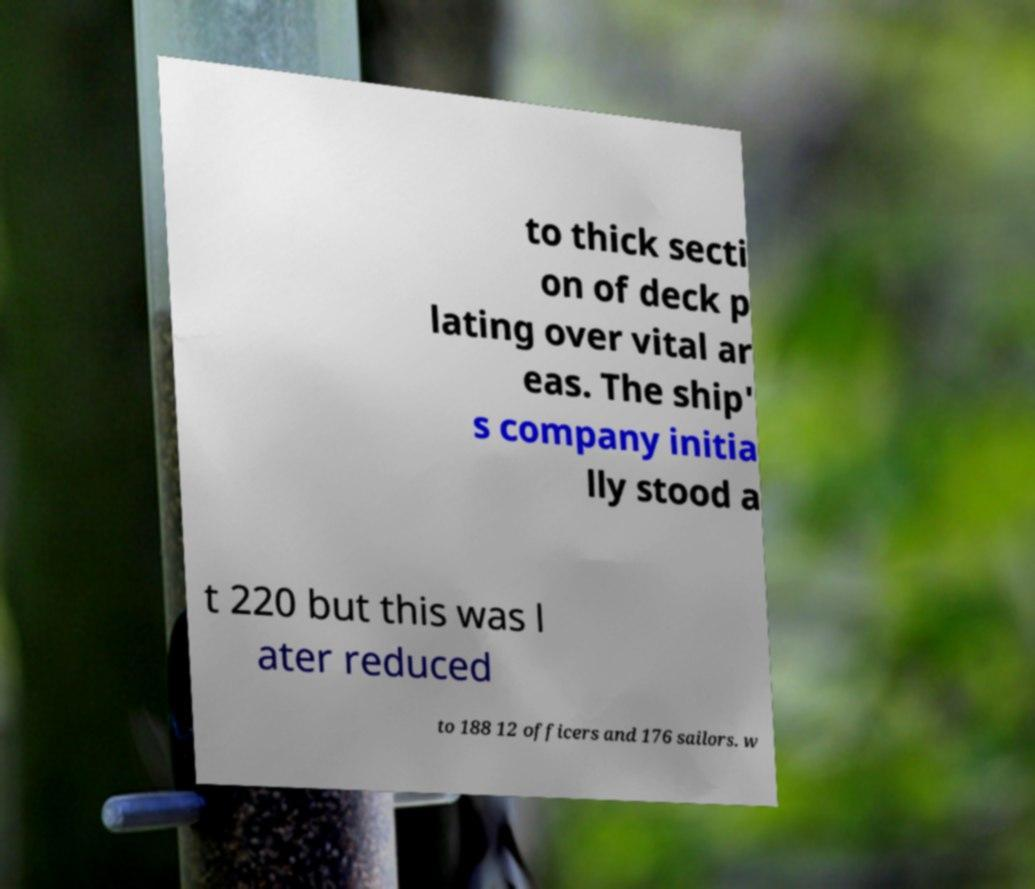Please read and relay the text visible in this image. What does it say? to thick secti on of deck p lating over vital ar eas. The ship' s company initia lly stood a t 220 but this was l ater reduced to 188 12 officers and 176 sailors. w 